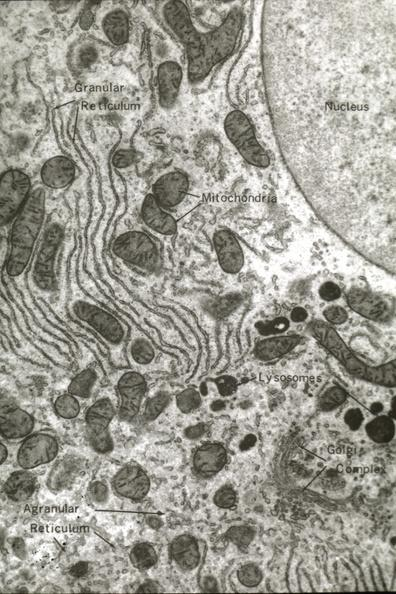s traumatic rupture present?
Answer the question using a single word or phrase. No 